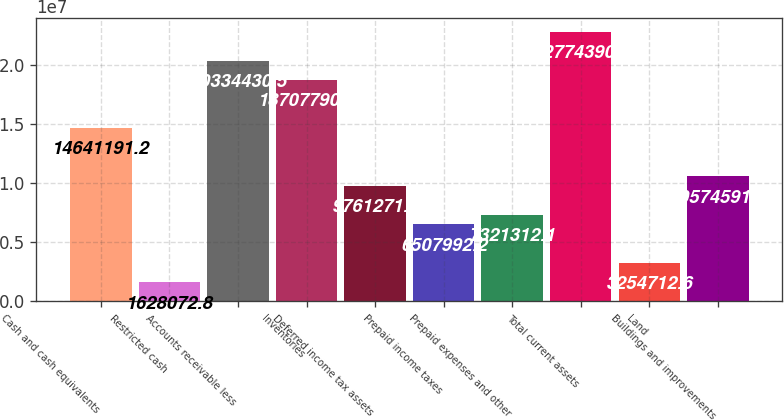Convert chart to OTSL. <chart><loc_0><loc_0><loc_500><loc_500><bar_chart><fcel>Cash and cash equivalents<fcel>Restricted cash<fcel>Accounts receivable less<fcel>Inventories<fcel>Deferred income tax assets<fcel>Prepaid income taxes<fcel>Prepaid expenses and other<fcel>Total current assets<fcel>Land<fcel>Buildings and improvements<nl><fcel>1.46412e+07<fcel>1.62807e+06<fcel>2.03344e+07<fcel>1.87078e+07<fcel>9.76127e+06<fcel>6.50799e+06<fcel>7.32131e+06<fcel>2.27744e+07<fcel>3.25471e+06<fcel>1.05746e+07<nl></chart> 